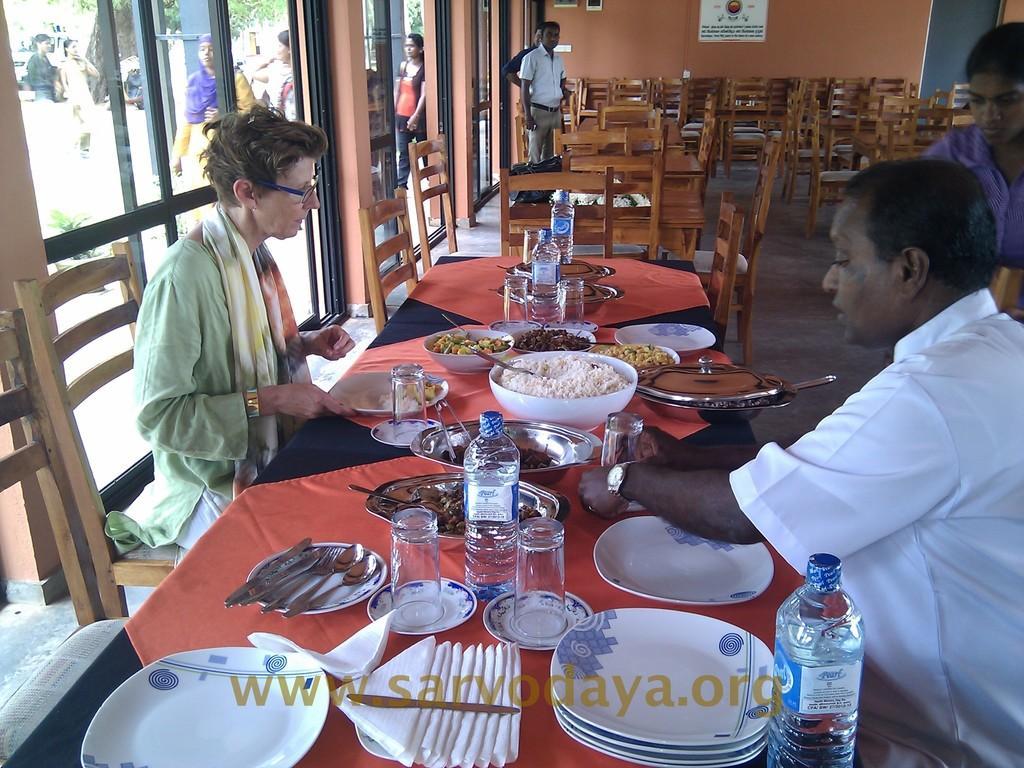How would you summarize this image in a sentence or two? In this picture we can see two persons are sitting on the chairs. This is table. On the table there are plates, glasses, bottles, spoons, bowl, and some food. This is floor. Here we can see some persons are standing on the floor. This is glass and there is a wall. 